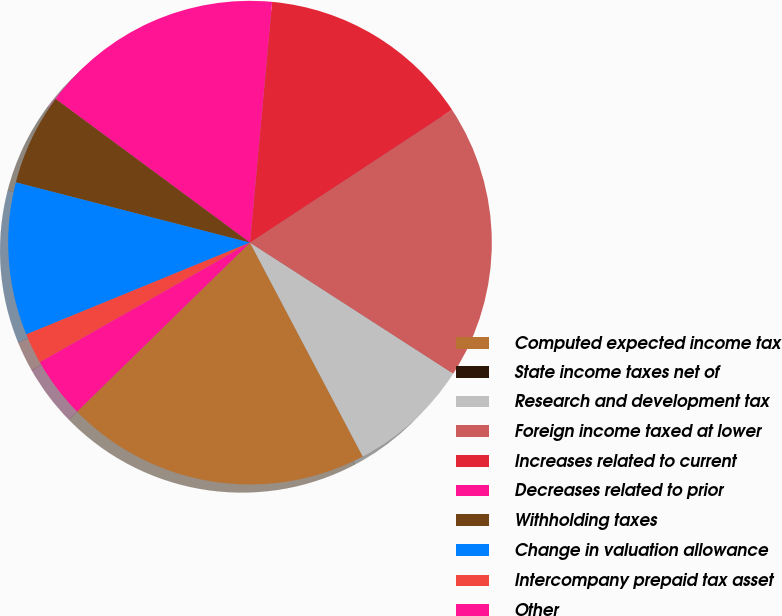<chart> <loc_0><loc_0><loc_500><loc_500><pie_chart><fcel>Computed expected income tax<fcel>State income taxes net of<fcel>Research and development tax<fcel>Foreign income taxed at lower<fcel>Increases related to current<fcel>Decreases related to prior<fcel>Withholding taxes<fcel>Change in valuation allowance<fcel>Intercompany prepaid tax asset<fcel>Other<nl><fcel>20.4%<fcel>0.0%<fcel>8.16%<fcel>18.36%<fcel>14.28%<fcel>16.32%<fcel>6.12%<fcel>10.2%<fcel>2.04%<fcel>4.08%<nl></chart> 